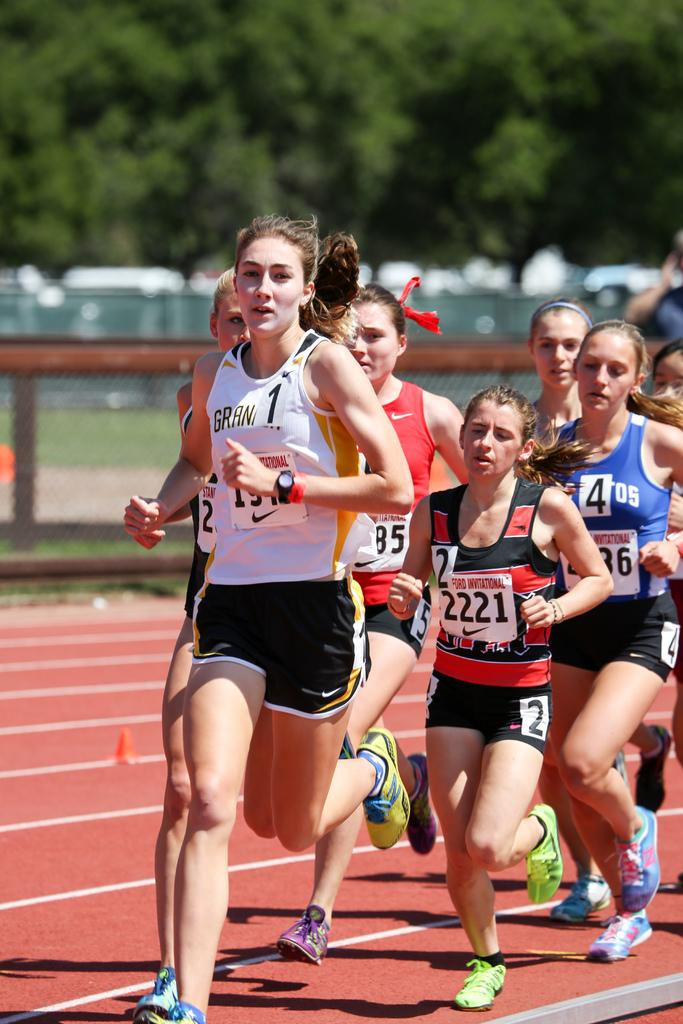Provide a one-sentence caption for the provided image. Girls running in the Ford Invitational race sponsored by Nike. 